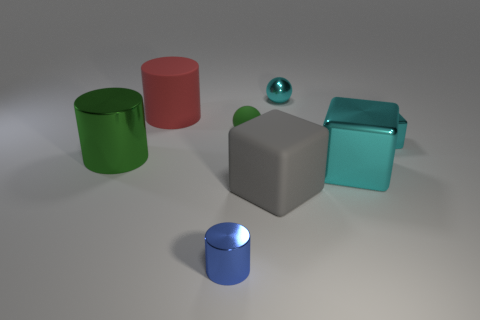There is a cylinder that is the same color as the tiny matte ball; what is its material?
Your answer should be very brief. Metal. How many things are rubber things right of the tiny metal cylinder or cyan shiny things in front of the small green ball?
Your answer should be compact. 4. There is a large thing in front of the large metallic thing that is on the right side of the matte object that is left of the tiny metal cylinder; what is its material?
Provide a short and direct response. Rubber. Is the color of the tiny metallic thing in front of the green cylinder the same as the tiny shiny sphere?
Your answer should be compact. No. There is a large thing that is behind the gray thing and to the right of the red matte cylinder; what is its material?
Keep it short and to the point. Metal. Is there a yellow matte thing that has the same size as the gray object?
Your answer should be compact. No. How many small objects are there?
Keep it short and to the point. 4. There is a big gray matte thing; what number of tiny things are on the left side of it?
Your answer should be compact. 2. Does the small block have the same material as the small cyan sphere?
Offer a terse response. Yes. What number of shiny things are both to the left of the small cyan ball and on the right side of the big cyan cube?
Keep it short and to the point. 0. 